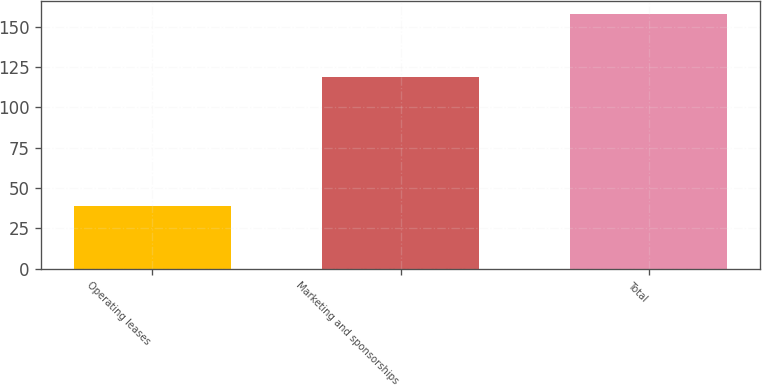Convert chart to OTSL. <chart><loc_0><loc_0><loc_500><loc_500><bar_chart><fcel>Operating leases<fcel>Marketing and sponsorships<fcel>Total<nl><fcel>39<fcel>119<fcel>158<nl></chart> 